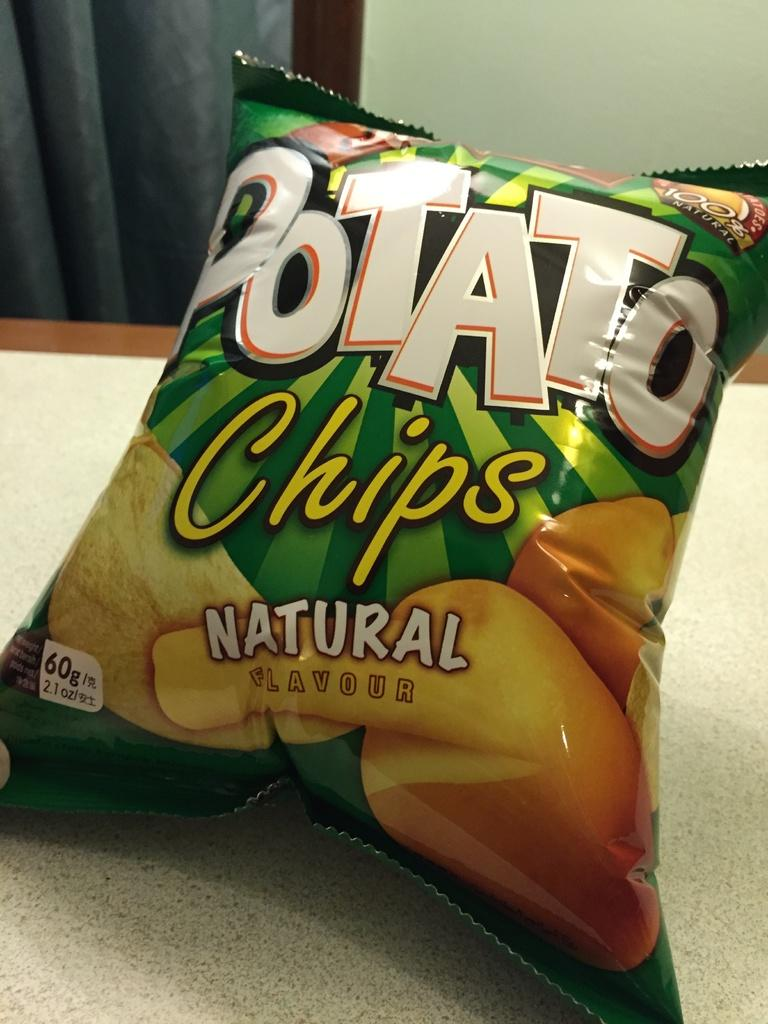What is the main object in the image? There is a chips packet in the image. Where is the chips packet located in the image? The chips packet is in the front of the image. What can be seen in the background of the image? There is a wall visible in the background of the image. What type of metal is the hand holding in the image? There is no hand or metal present in the image; it only features a chips packet. 